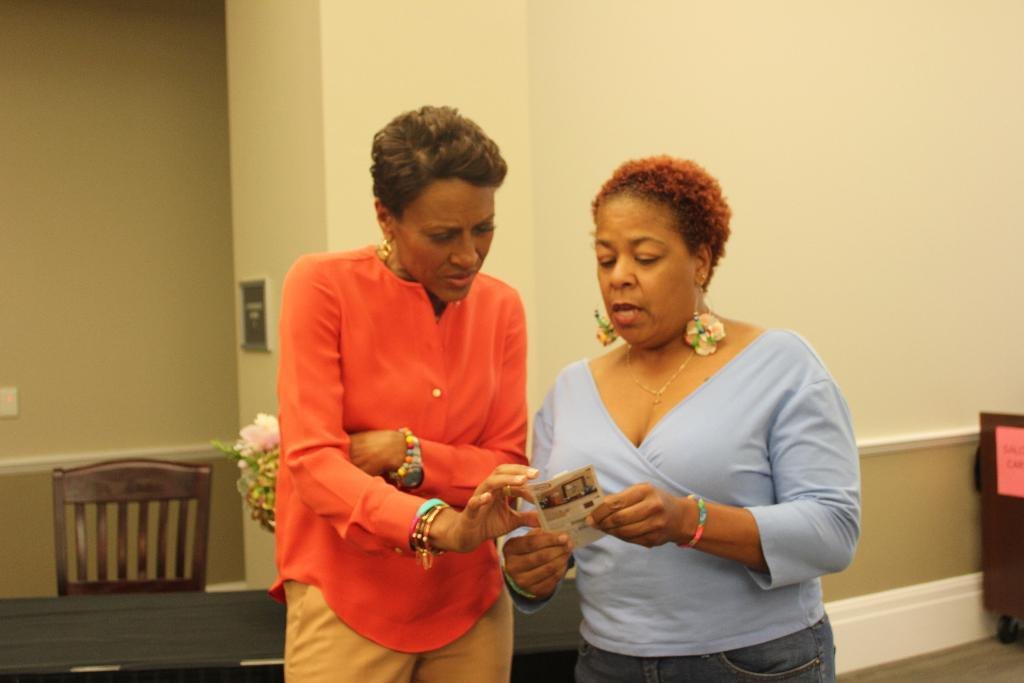What is the woman holding in the image? There is a woman holding a card in the image. What is the other woman doing in relation to the card? The other woman is looking at the card. What can be seen in the background of the image? There is a table, a chair, and a wall in the background of the image. What color is the orange ray emitting from the woman's hand in the image? There is no orange ray present in the image. The woman is simply holding a card, and there are no rays or oranges mentioned in the facts provided. 